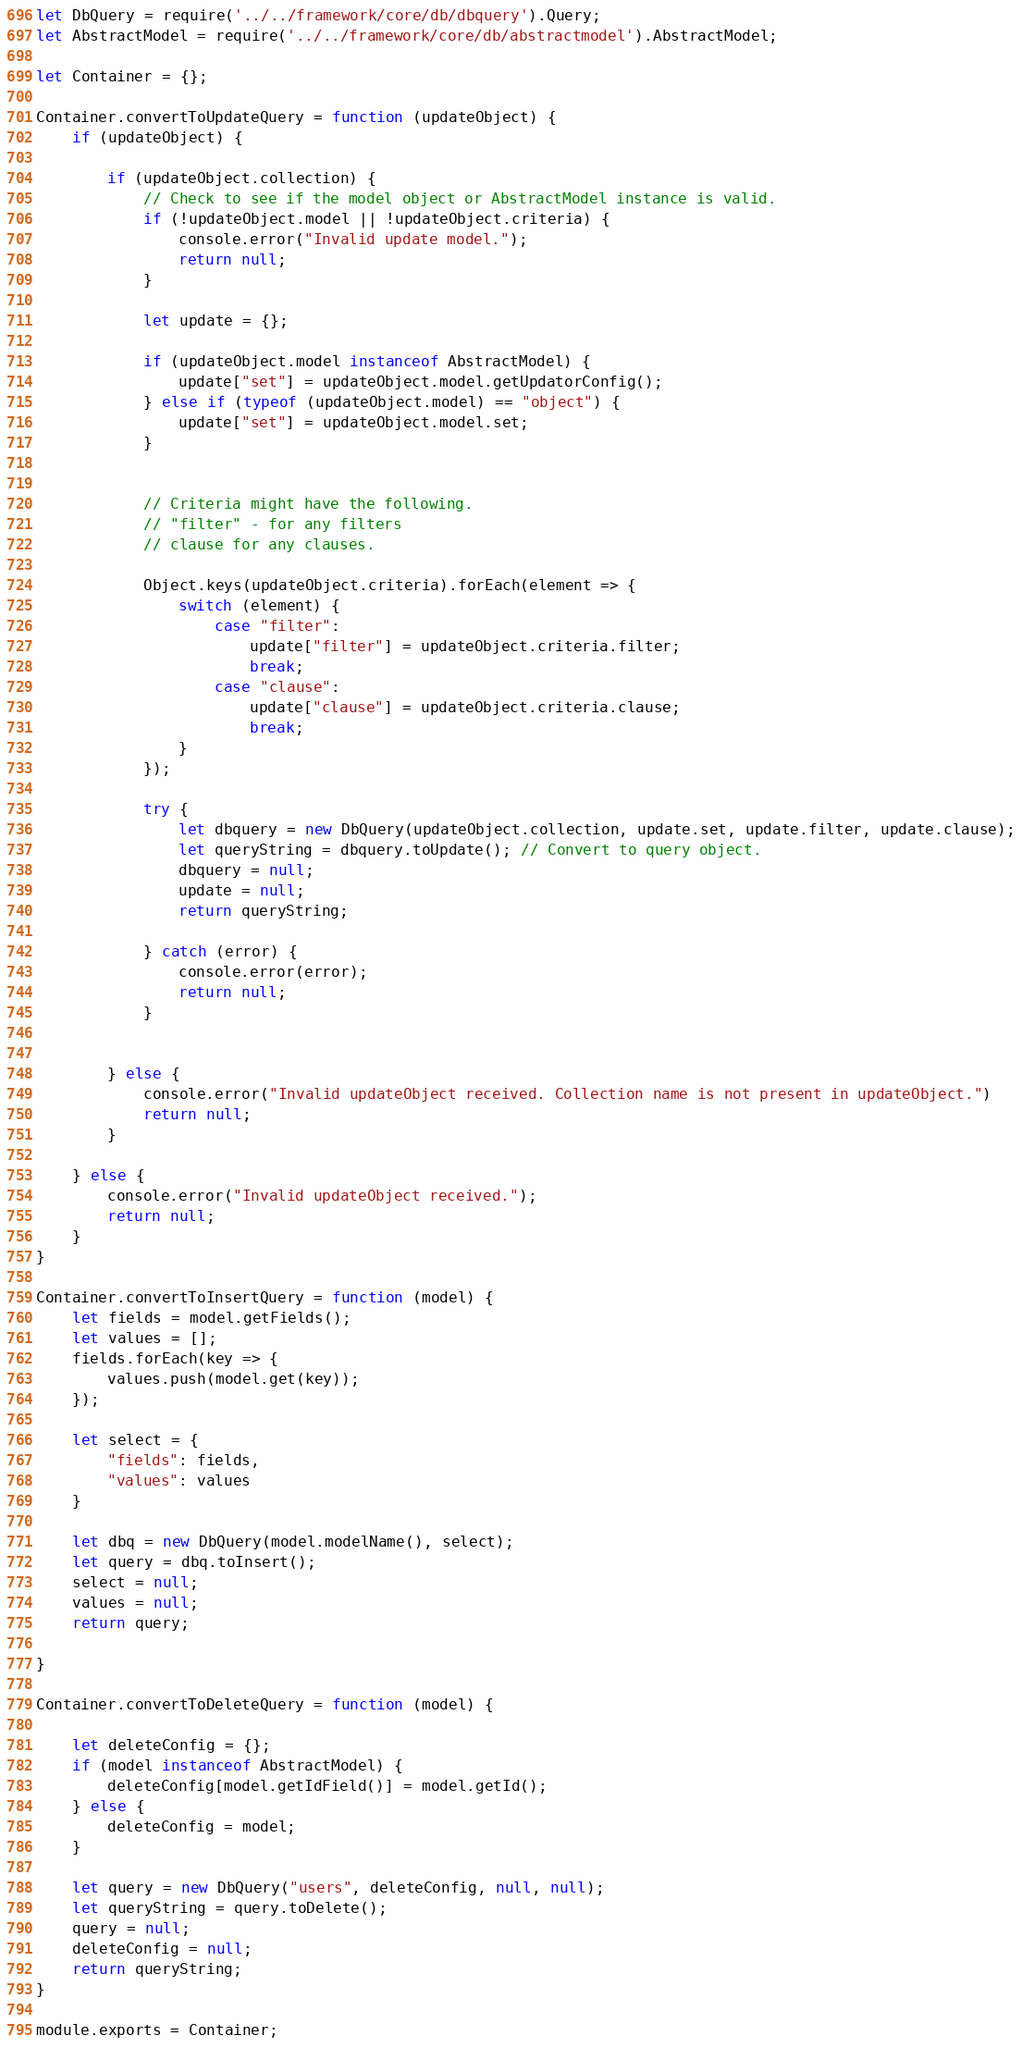<code> <loc_0><loc_0><loc_500><loc_500><_JavaScript_>let DbQuery = require('../../framework/core/db/dbquery').Query;
let AbstractModel = require('../../framework/core/db/abstractmodel').AbstractModel;

let Container = {};

Container.convertToUpdateQuery = function (updateObject) {
    if (updateObject) {

        if (updateObject.collection) {
            // Check to see if the model object or AbstractModel instance is valid.
            if (!updateObject.model || !updateObject.criteria) {
                console.error("Invalid update model.");
                return null;
            }

            let update = {};

            if (updateObject.model instanceof AbstractModel) {
                update["set"] = updateObject.model.getUpdatorConfig();
            } else if (typeof (updateObject.model) == "object") {
                update["set"] = updateObject.model.set;
            }


            // Criteria might have the following.
            // "filter" - for any filters
            // clause for any clauses.

            Object.keys(updateObject.criteria).forEach(element => {
                switch (element) {
                    case "filter":
                        update["filter"] = updateObject.criteria.filter;
                        break;
                    case "clause":
                        update["clause"] = updateObject.criteria.clause;
                        break;
                }
            });

            try {
                let dbquery = new DbQuery(updateObject.collection, update.set, update.filter, update.clause);
                let queryString = dbquery.toUpdate(); // Convert to query object.
                dbquery = null;
                update = null;
                return queryString;

            } catch (error) {
                console.error(error);
                return null;
            }


        } else {
            console.error("Invalid updateObject received. Collection name is not present in updateObject.")
            return null;
        }

    } else {
        console.error("Invalid updateObject received.");
        return null;
    }
}

Container.convertToInsertQuery = function (model) {
    let fields = model.getFields();
    let values = [];
    fields.forEach(key => {
        values.push(model.get(key));
    });

    let select = {
        "fields": fields,
        "values": values
    }

    let dbq = new DbQuery(model.modelName(), select);
    let query = dbq.toInsert();
    select = null;
    values = null;
    return query;

}

Container.convertToDeleteQuery = function (model) {

    let deleteConfig = {};
    if (model instanceof AbstractModel) {
        deleteConfig[model.getIdField()] = model.getId();
    } else {
        deleteConfig = model;
    }

    let query = new DbQuery("users", deleteConfig, null, null);
    let queryString = query.toDelete();
    query = null;
    deleteConfig = null;
    return queryString;
}

module.exports = Container;</code> 